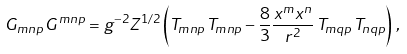<formula> <loc_0><loc_0><loc_500><loc_500>G _ { m n p } \, G ^ { m n p } = g ^ { - 2 } Z ^ { 1 / 2 } \left ( T _ { m n p } \, T _ { m n p } - \frac { 8 } { 3 } \frac { x ^ { m } x ^ { n } } { r ^ { 2 } } \, T _ { m q p } \, T _ { n q p } \right ) \, ,</formula> 